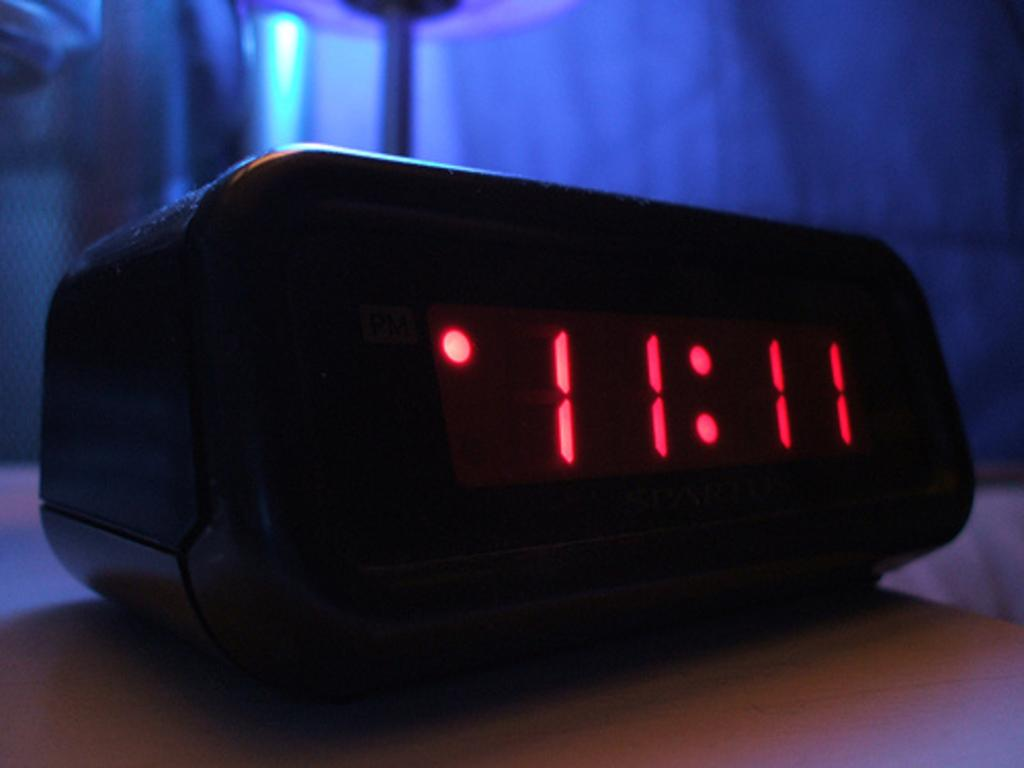Provide a one-sentence caption for the provided image. A black digital clock sits on a table and displays the time 11:11 in red digits. 